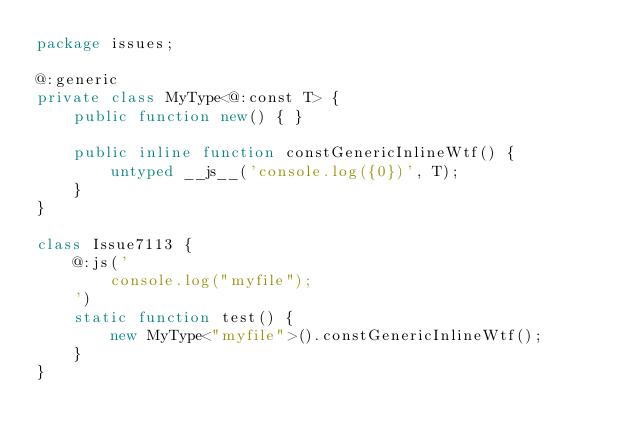Convert code to text. <code><loc_0><loc_0><loc_500><loc_500><_Haxe_>package issues;

@:generic
private class MyType<@:const T> {
    public function new() { }

	public inline function constGenericInlineWtf() {
        untyped __js__('console.log({0})', T);
    }
}

class Issue7113 {
	@:js('
		console.log("myfile");
	')
	static function test() {
		new MyType<"myfile">().constGenericInlineWtf();
	}
}</code> 